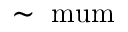<formula> <loc_0><loc_0><loc_500><loc_500>\sim \ m u m</formula> 